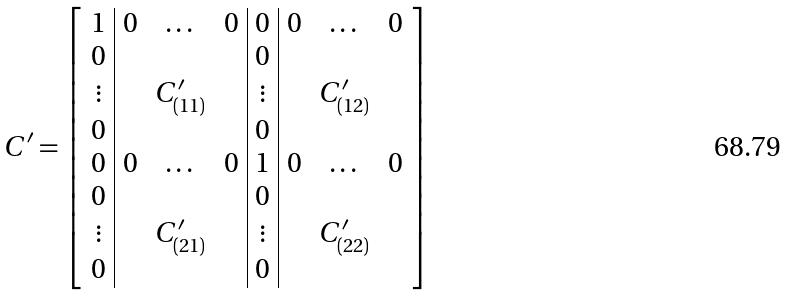Convert formula to latex. <formula><loc_0><loc_0><loc_500><loc_500>C ^ { \prime } = \left [ \begin{array} { c | c c c | c | c c c } 1 & 0 & \dots & 0 & 0 & 0 & \dots & 0 \\ 0 & & & & 0 & & & \\ \vdots & & C _ { ( 1 1 ) } ^ { \prime } & & \vdots & & C _ { ( 1 2 ) } ^ { \prime } & \\ 0 & & & & 0 & & & \\ 0 & 0 & \dots & 0 & 1 & 0 & \dots & 0 \\ 0 & & & & 0 & & & \\ \vdots & & C _ { ( 2 1 ) } ^ { \prime } & & \vdots & & C _ { ( 2 2 ) } ^ { \prime } & \\ 0 & & & & 0 & & & \end{array} \right ]</formula> 